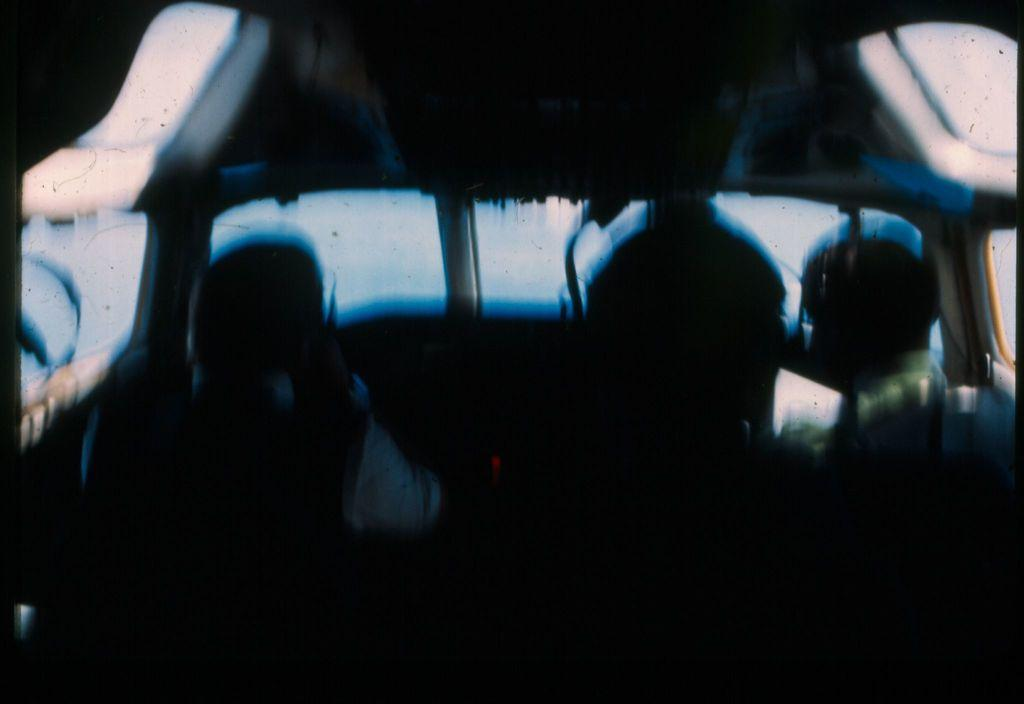What type of image is being described? The image is edited. What can be seen inside the image? The image shows an inside view of a vehicle. Are there any people present in the image? Yes, there are people inside the vehicle. What story is being told by the man's chin in the image? There is no man or chin present in the image, so no story can be told by a chin. 